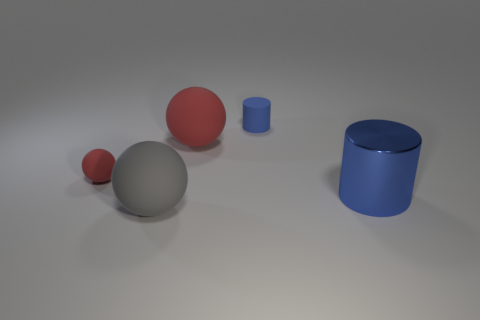There is a blue cylinder behind the big blue metallic cylinder; what number of big rubber objects are right of it?
Give a very brief answer. 0. Is there anything else that has the same color as the small cylinder?
Your answer should be very brief. Yes. How many objects are blue metal cylinders or blue objects that are to the right of the blue rubber object?
Your answer should be compact. 1. What material is the red object behind the matte sphere that is to the left of the matte thing in front of the big shiny object made of?
Ensure brevity in your answer.  Rubber. There is a gray object that is made of the same material as the small blue cylinder; what size is it?
Make the answer very short. Large. There is a large matte thing behind the red ball left of the gray rubber object; what is its color?
Keep it short and to the point. Red. How many spheres have the same material as the small red thing?
Offer a terse response. 2. What number of metal objects are red objects or big cylinders?
Give a very brief answer. 1. There is a red sphere that is the same size as the gray object; what material is it?
Keep it short and to the point. Rubber. Is there a large purple thing that has the same material as the big gray ball?
Keep it short and to the point. No. 